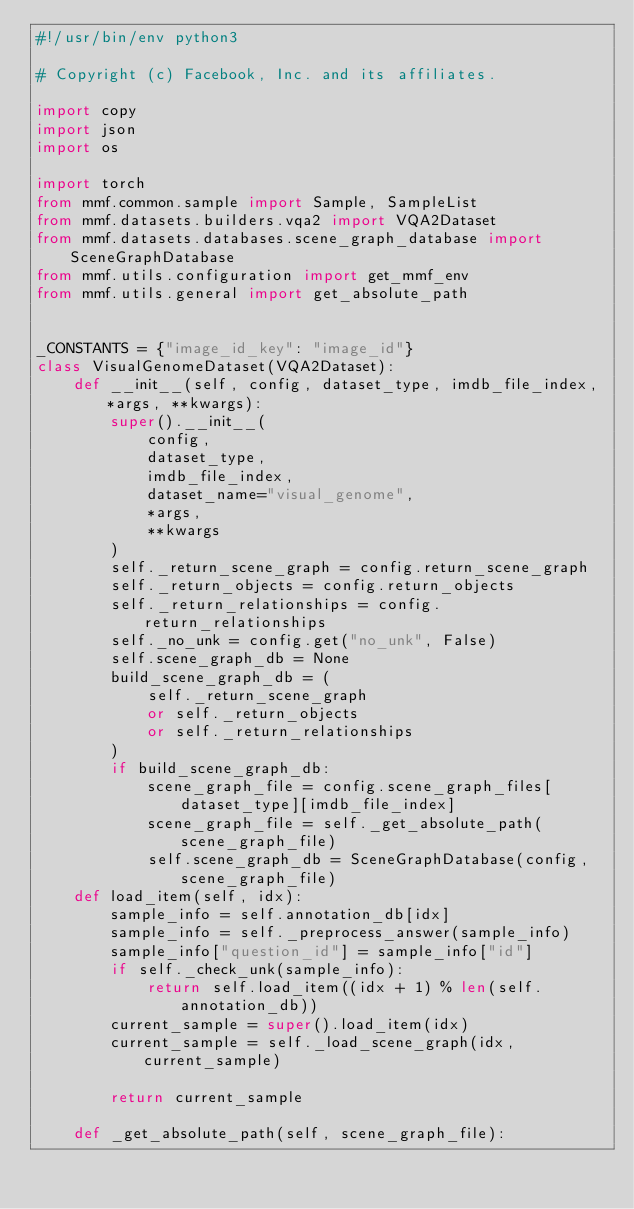Convert code to text. <code><loc_0><loc_0><loc_500><loc_500><_Python_>#!/usr/bin/env python3

# Copyright (c) Facebook, Inc. and its affiliates.

import copy
import json
import os

import torch
from mmf.common.sample import Sample, SampleList
from mmf.datasets.builders.vqa2 import VQA2Dataset
from mmf.datasets.databases.scene_graph_database import SceneGraphDatabase
from mmf.utils.configuration import get_mmf_env
from mmf.utils.general import get_absolute_path


_CONSTANTS = {"image_id_key": "image_id"}
class VisualGenomeDataset(VQA2Dataset):
    def __init__(self, config, dataset_type, imdb_file_index, *args, **kwargs):
        super().__init__(
            config,
            dataset_type,
            imdb_file_index,
            dataset_name="visual_genome",
            *args,
            **kwargs
        )
        self._return_scene_graph = config.return_scene_graph
        self._return_objects = config.return_objects
        self._return_relationships = config.return_relationships
        self._no_unk = config.get("no_unk", False)
        self.scene_graph_db = None
        build_scene_graph_db = (
            self._return_scene_graph
            or self._return_objects
            or self._return_relationships
        )
        if build_scene_graph_db:
            scene_graph_file = config.scene_graph_files[dataset_type][imdb_file_index]
            scene_graph_file = self._get_absolute_path(scene_graph_file)
            self.scene_graph_db = SceneGraphDatabase(config, scene_graph_file)
    def load_item(self, idx):
        sample_info = self.annotation_db[idx]
        sample_info = self._preprocess_answer(sample_info)
        sample_info["question_id"] = sample_info["id"]
        if self._check_unk(sample_info):
            return self.load_item((idx + 1) % len(self.annotation_db))
        current_sample = super().load_item(idx)
        current_sample = self._load_scene_graph(idx, current_sample)

        return current_sample

    def _get_absolute_path(self, scene_graph_file):</code> 